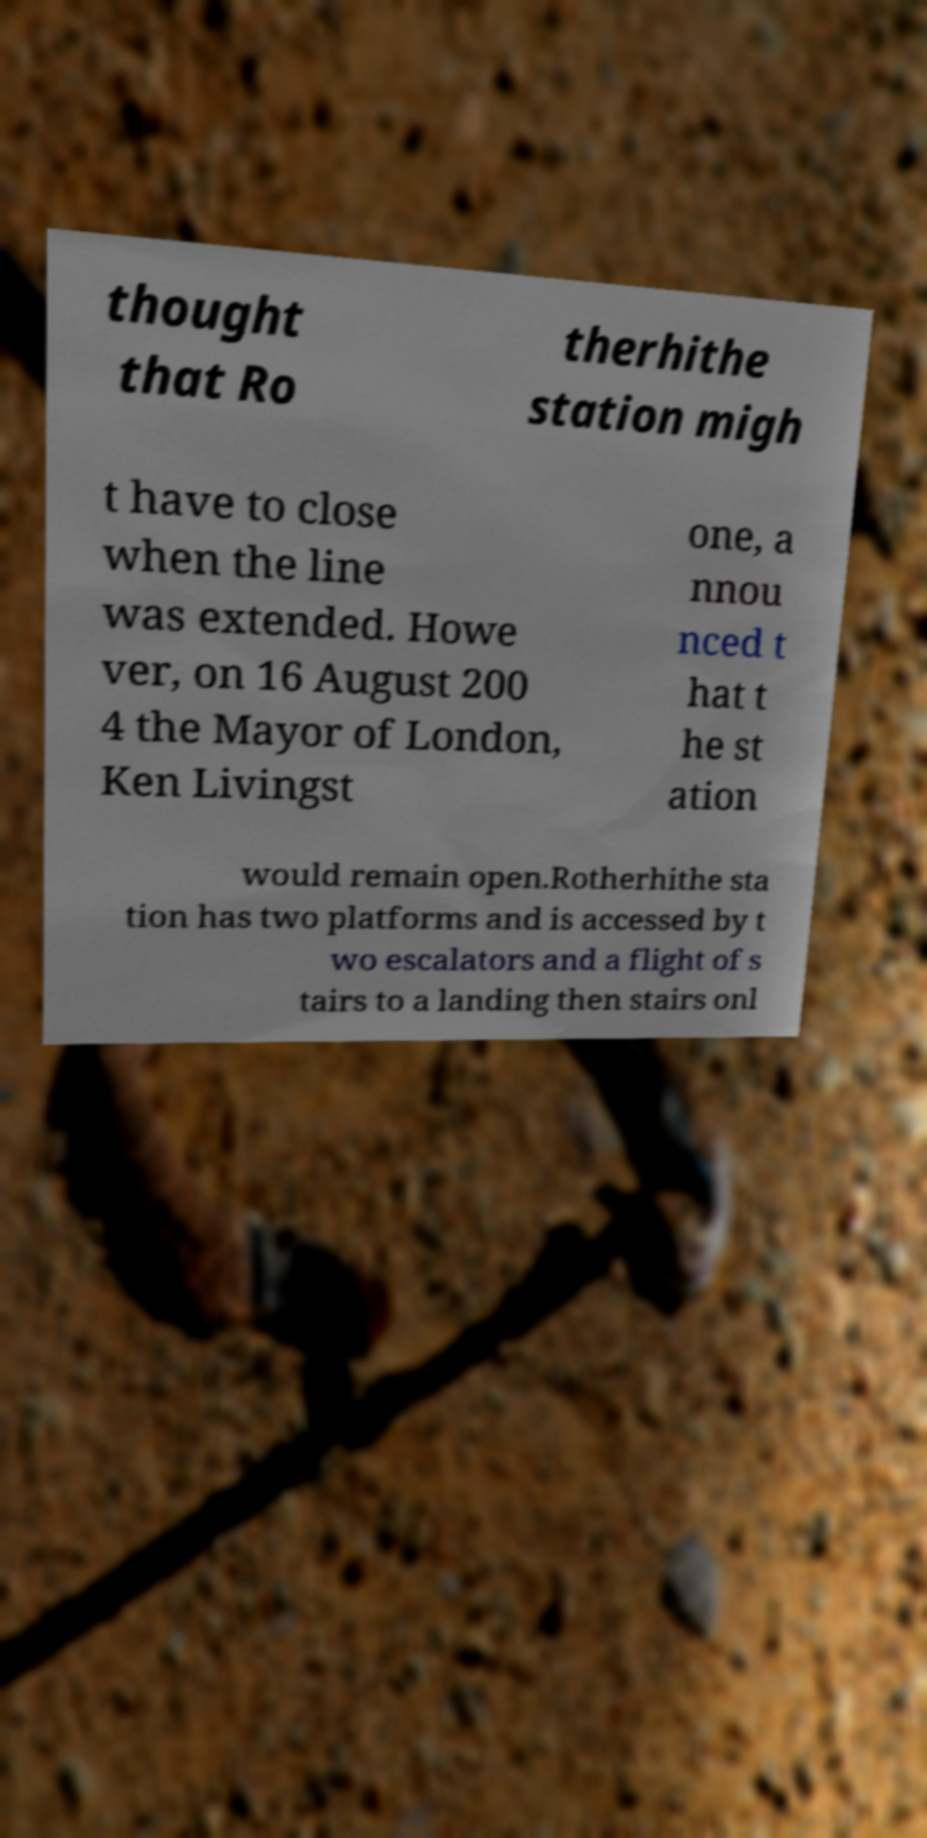Can you accurately transcribe the text from the provided image for me? thought that Ro therhithe station migh t have to close when the line was extended. Howe ver, on 16 August 200 4 the Mayor of London, Ken Livingst one, a nnou nced t hat t he st ation would remain open.Rotherhithe sta tion has two platforms and is accessed by t wo escalators and a flight of s tairs to a landing then stairs onl 